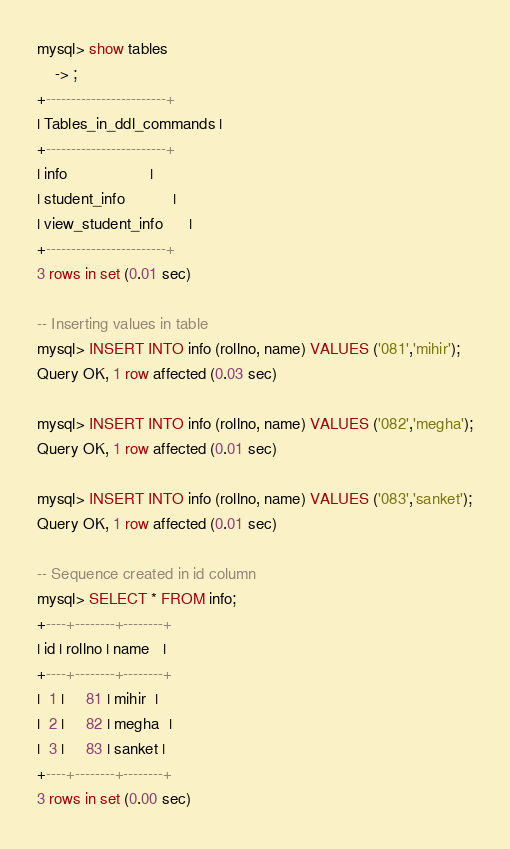<code> <loc_0><loc_0><loc_500><loc_500><_SQL_>
mysql> show tables
    -> ;
+------------------------+
| Tables_in_ddl_commands |
+------------------------+
| info                   |
| student_info           |
| view_student_info      |
+------------------------+
3 rows in set (0.01 sec)

-- Inserting values in table
mysql> INSERT INTO info (rollno, name) VALUES ('081','mihir');
Query OK, 1 row affected (0.03 sec)

mysql> INSERT INTO info (rollno, name) VALUES ('082','megha');
Query OK, 1 row affected (0.01 sec)

mysql> INSERT INTO info (rollno, name) VALUES ('083','sanket');
Query OK, 1 row affected (0.01 sec)

-- Sequence created in id column 
mysql> SELECT * FROM info;
+----+--------+--------+
| id | rollno | name   |
+----+--------+--------+
|  1 |     81 | mihir  |
|  2 |     82 | megha  |
|  3 |     83 | sanket |
+----+--------+--------+
3 rows in set (0.00 sec)</code> 